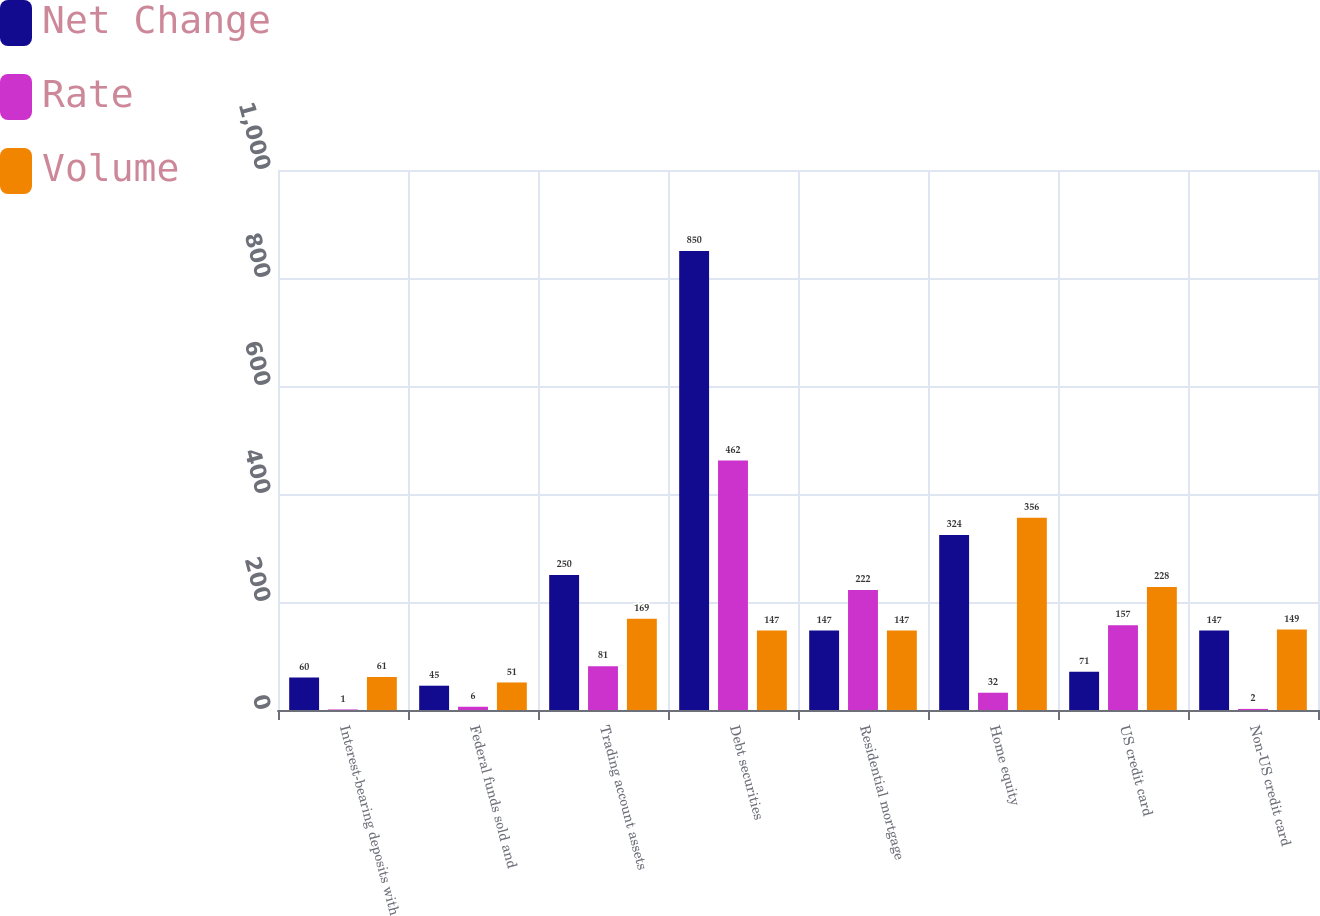<chart> <loc_0><loc_0><loc_500><loc_500><stacked_bar_chart><ecel><fcel>Interest-bearing deposits with<fcel>Federal funds sold and<fcel>Trading account assets<fcel>Debt securities<fcel>Residential mortgage<fcel>Home equity<fcel>US credit card<fcel>Non-US credit card<nl><fcel>Net Change<fcel>60<fcel>45<fcel>250<fcel>850<fcel>147<fcel>324<fcel>71<fcel>147<nl><fcel>Rate<fcel>1<fcel>6<fcel>81<fcel>462<fcel>222<fcel>32<fcel>157<fcel>2<nl><fcel>Volume<fcel>61<fcel>51<fcel>169<fcel>147<fcel>147<fcel>356<fcel>228<fcel>149<nl></chart> 